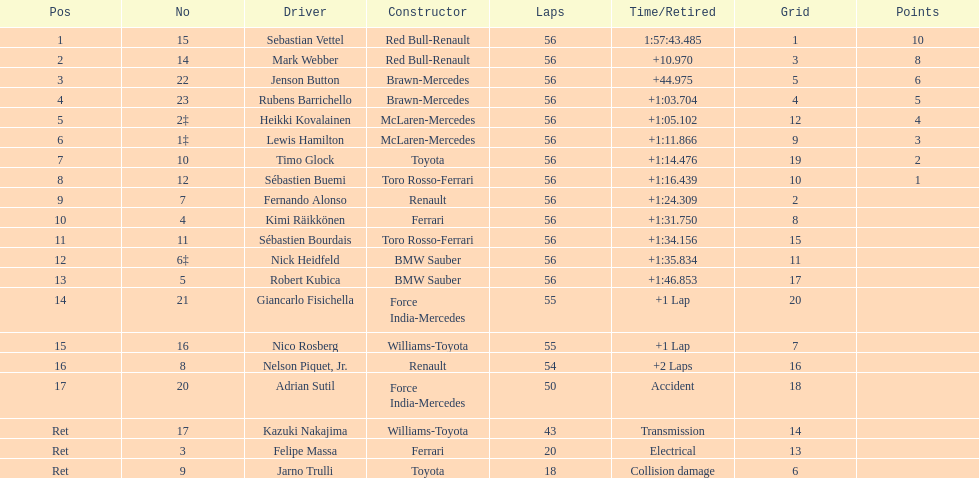What name is just previous to kazuki nakjima on the list? Adrian Sutil. 